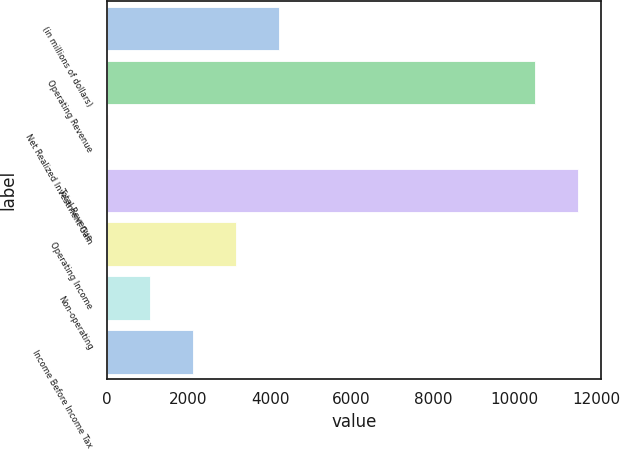Convert chart. <chart><loc_0><loc_0><loc_500><loc_500><bar_chart><fcel>(in millions of dollars)<fcel>Operating Revenue<fcel>Net Realized Investment Gain<fcel>Total Revenue<fcel>Operating Income<fcel>Non-operating<fcel>Income Before Income Tax<nl><fcel>4213.54<fcel>10493.6<fcel>16.1<fcel>11543<fcel>3164.18<fcel>1065.46<fcel>2114.82<nl></chart> 